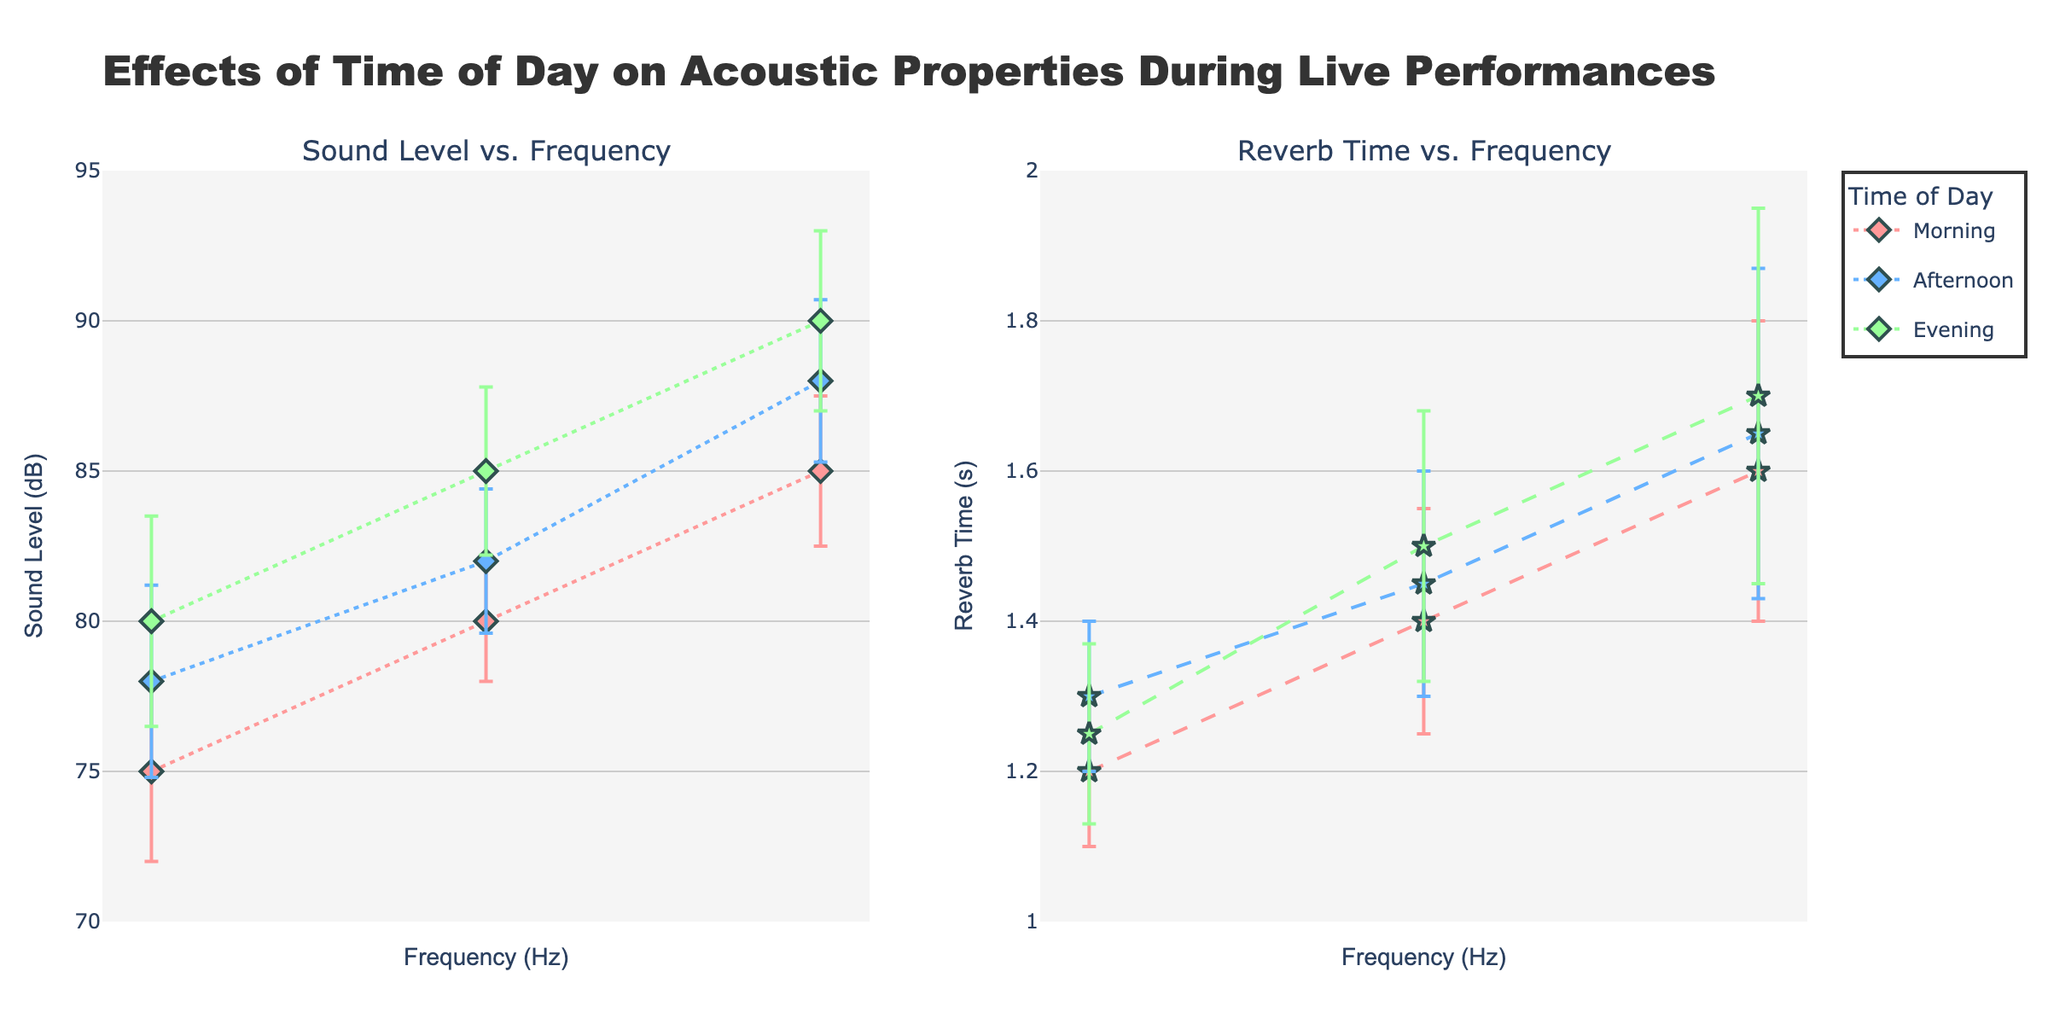What's the title of the figure? The title of the figure is displayed at the top. It reads "Effects of Time of Day on Acoustic Properties During Live Performances."
Answer: "Effects of Time of Day on Acoustic Properties During Live Performances" What does the x-axis represent in both subplots? The x-axis in both subplots represents Frequency in Hz.
Answer: Frequency (Hz) How many different times of day are represented in the figure? The legend shows three different times of day: Morning, Afternoon, and Evening.
Answer: 3 Which time of day has the highest sound level at 500Hz? On the sound level subplot, the highest sound level at 500Hz is marked by the Evening line and marker.
Answer: Evening What is the error range for reverb time at 500Hz in the afternoon? For reverb time at 500Hz in the afternoon, the reverb is marked at 1.65s with an error of 0.22s, so the range is (1.65 ± 0.22) seconds.
Answer: 1.65 ± 0.22 seconds What is the difference in sound level between morning and evening at 250Hz? The Sound Level at 250Hz is 80 dB for Morning and 85 dB for Evening. The difference is 85 - 80 = 5 dB.
Answer: 5 dB What's the average reverb time across all times of day at 250Hz? Reverb times at 250Hz are 1.4s (Morning), 1.45s (Afternoon), and 1.5s (Evening). Average = (1.4 + 1.45 + 1.5) / 3 = 4.35/3 = 1.45s.
Answer: 1.45s How does the sound level error compare between Morning and Afternoon at 100Hz? Morning has an error of 3 dB and Afternoon has an error of 3.2 dB at 100Hz. Afternoon's error is 0.2 dB higher than Morning's.
Answer: Afternoon is 0.2 dB higher Which time of day has the smallest range of errors in reverb time? The ranges of errors for reverb time are Morning (0.1 to 0.2s), Afternoon (0.1 to 0.22s), and Evening (0.12 to 0.25s). Morning has the smallest range (0.1s to 0.2s).
Answer: Morning What can you infer about the relationship between frequency and reverb time across different times of the day? Across different times of day, reverb time generally increases with frequency, with slight variations between Morning, Afternoon, and Evening.
Answer: Reverb time increases with frequency 